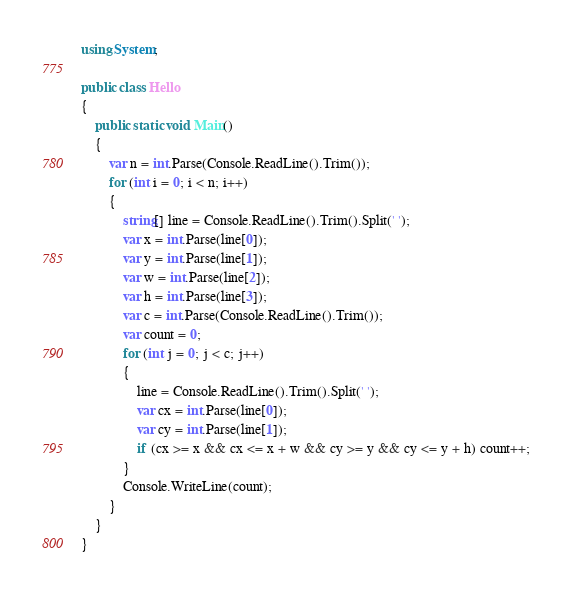<code> <loc_0><loc_0><loc_500><loc_500><_C#_>using System;

public class Hello
{
    public static void Main()
    {
        var n = int.Parse(Console.ReadLine().Trim());
        for (int i = 0; i < n; i++)
        {
            string[] line = Console.ReadLine().Trim().Split(' ');
            var x = int.Parse(line[0]);
            var y = int.Parse(line[1]);
            var w = int.Parse(line[2]);
            var h = int.Parse(line[3]);
            var c = int.Parse(Console.ReadLine().Trim());
            var count = 0;
            for (int j = 0; j < c; j++)
            {
                line = Console.ReadLine().Trim().Split(' ');
                var cx = int.Parse(line[0]);
                var cy = int.Parse(line[1]);
                if (cx >= x && cx <= x + w && cy >= y && cy <= y + h) count++;
            }
            Console.WriteLine(count);
        }
    }
}
</code> 